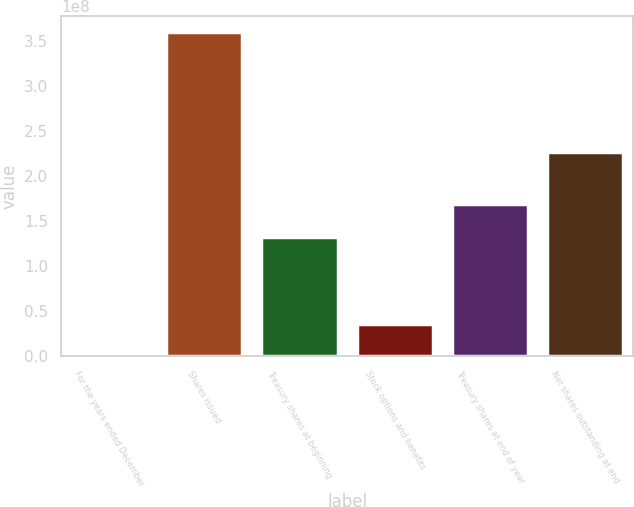Convert chart to OTSL. <chart><loc_0><loc_0><loc_500><loc_500><bar_chart><fcel>For the years ended December<fcel>Shares issued<fcel>Treasury shares at beginning<fcel>Stock options and benefits<fcel>Treasury shares at end of year<fcel>Net shares outstanding at end<nl><fcel>2008<fcel>3.59902e+08<fcel>1.32852e+08<fcel>3.5992e+07<fcel>1.68842e+08<fcel>2.27035e+08<nl></chart> 